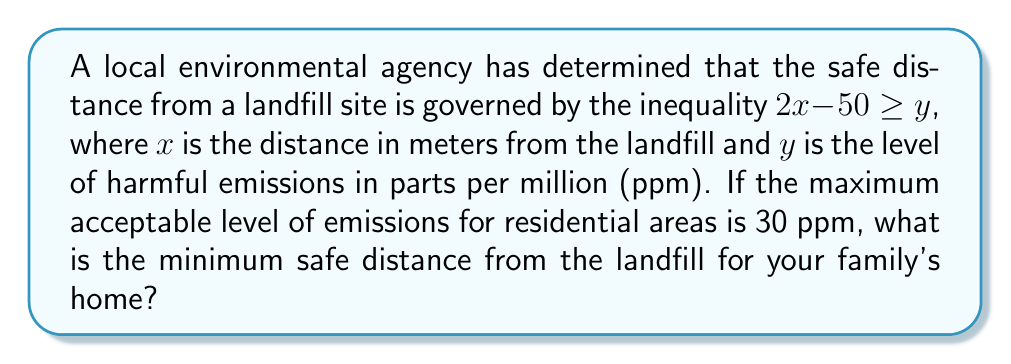Could you help me with this problem? To solve this problem, we'll follow these steps:

1. Identify the given inequality: $2x - 50 \geq y$

2. Substitute the maximum acceptable emission level:
   $2x - 50 \geq 30$

3. Solve the inequality for $x$:
   $2x \geq 30 + 50$
   $2x \geq 80$
   
   Divide both sides by 2:
   $x \geq 40$

4. Interpret the result:
   The minimum safe distance $x$ is greater than or equal to 40 meters.

5. Since we're looking for the minimum safe distance, we take the smallest value that satisfies the inequality, which is 40 meters.
Answer: 40 meters 